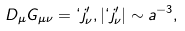<formula> <loc_0><loc_0><loc_500><loc_500>D _ { \mu } G _ { \mu \nu } = ` j _ { \nu } ^ { \prime } , | ` j _ { \nu } ^ { \prime } | \sim a ^ { - 3 } ,</formula> 